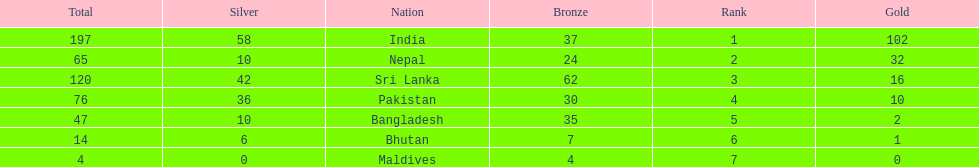How many gold medals did india win? 102. 